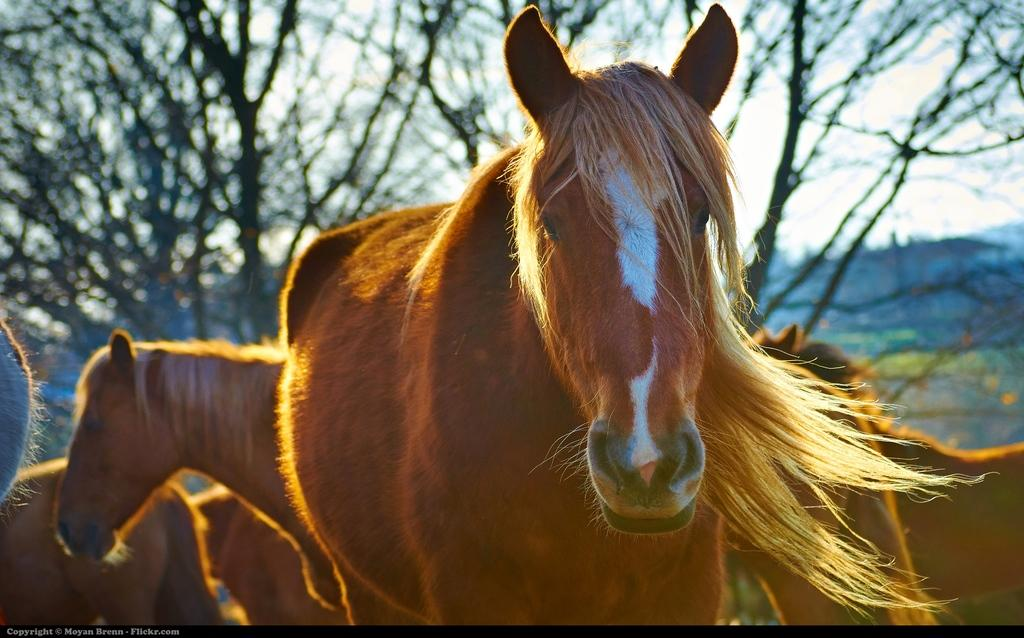What animals are present in the image? There are horses in the image. Where are the horses located in the image? The horses are in the center of the image. What can be seen in the background of the image? There are trees in the background of the image. What type of trade is being conducted between the horses in the image? There is no indication of any trade being conducted between the horses in the image. 